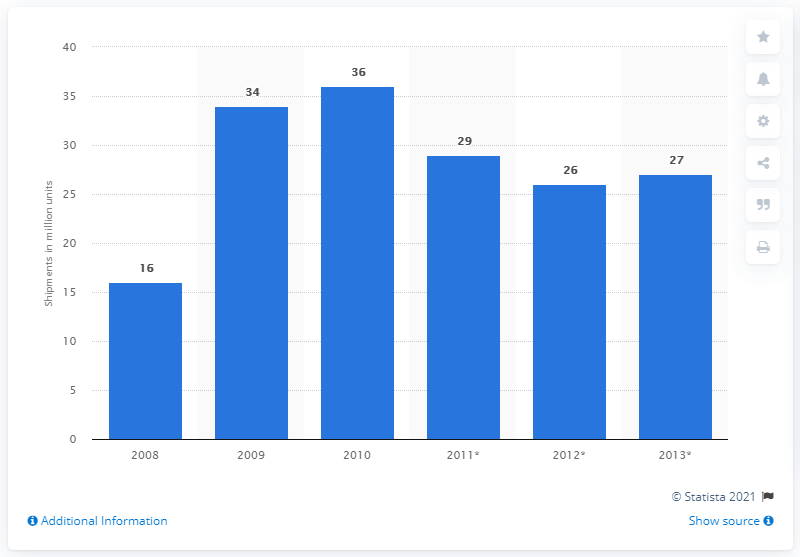Indicate a few pertinent items in this graphic. In 2008, a total of 16 million netbook devices were shipped worldwide. 